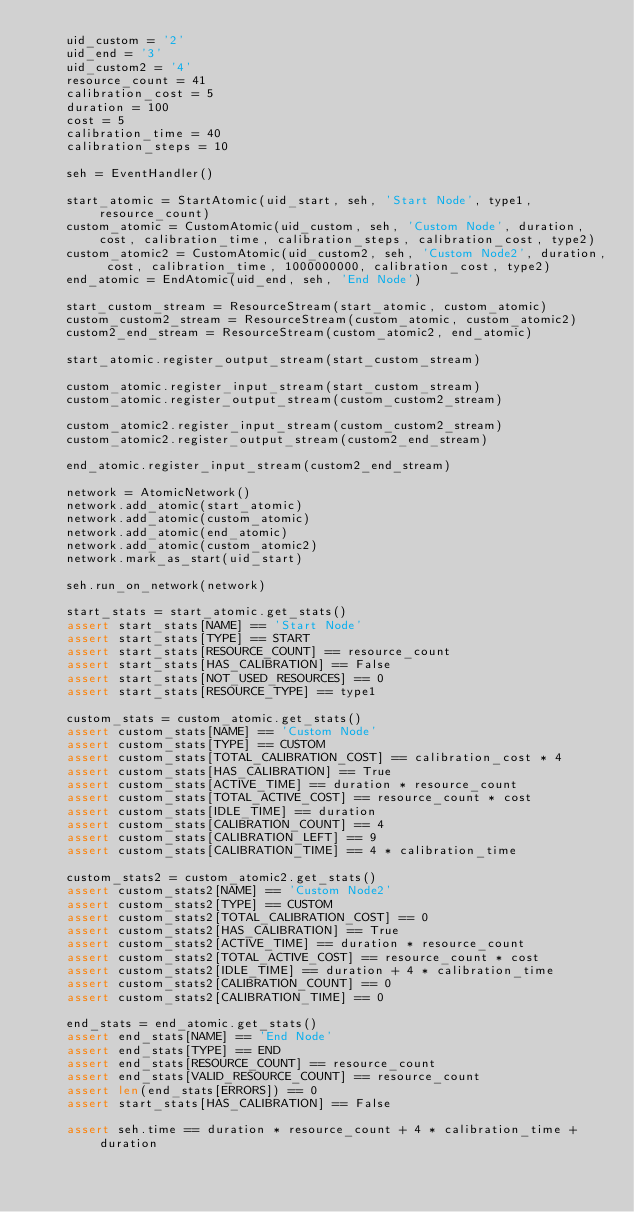<code> <loc_0><loc_0><loc_500><loc_500><_Python_>    uid_custom = '2'
    uid_end = '3'
    uid_custom2 = '4'
    resource_count = 41
    calibration_cost = 5
    duration = 100
    cost = 5
    calibration_time = 40
    calibration_steps = 10

    seh = EventHandler()

    start_atomic = StartAtomic(uid_start, seh, 'Start Node', type1, resource_count)
    custom_atomic = CustomAtomic(uid_custom, seh, 'Custom Node', duration, cost, calibration_time, calibration_steps, calibration_cost, type2)
    custom_atomic2 = CustomAtomic(uid_custom2, seh, 'Custom Node2', duration, cost, calibration_time, 1000000000, calibration_cost, type2)
    end_atomic = EndAtomic(uid_end, seh, 'End Node')

    start_custom_stream = ResourceStream(start_atomic, custom_atomic)
    custom_custom2_stream = ResourceStream(custom_atomic, custom_atomic2)
    custom2_end_stream = ResourceStream(custom_atomic2, end_atomic)

    start_atomic.register_output_stream(start_custom_stream)

    custom_atomic.register_input_stream(start_custom_stream)
    custom_atomic.register_output_stream(custom_custom2_stream)

    custom_atomic2.register_input_stream(custom_custom2_stream)
    custom_atomic2.register_output_stream(custom2_end_stream)

    end_atomic.register_input_stream(custom2_end_stream)

    network = AtomicNetwork()
    network.add_atomic(start_atomic)
    network.add_atomic(custom_atomic)
    network.add_atomic(end_atomic)
    network.add_atomic(custom_atomic2)
    network.mark_as_start(uid_start)

    seh.run_on_network(network)

    start_stats = start_atomic.get_stats()
    assert start_stats[NAME] == 'Start Node'
    assert start_stats[TYPE] == START
    assert start_stats[RESOURCE_COUNT] == resource_count
    assert start_stats[HAS_CALIBRATION] == False
    assert start_stats[NOT_USED_RESOURCES] == 0
    assert start_stats[RESOURCE_TYPE] == type1

    custom_stats = custom_atomic.get_stats()
    assert custom_stats[NAME] == 'Custom Node'
    assert custom_stats[TYPE] == CUSTOM
    assert custom_stats[TOTAL_CALIBRATION_COST] == calibration_cost * 4
    assert custom_stats[HAS_CALIBRATION] == True
    assert custom_stats[ACTIVE_TIME] == duration * resource_count
    assert custom_stats[TOTAL_ACTIVE_COST] == resource_count * cost
    assert custom_stats[IDLE_TIME] == duration
    assert custom_stats[CALIBRATION_COUNT] == 4
    assert custom_stats[CALIBRATION_LEFT] == 9
    assert custom_stats[CALIBRATION_TIME] == 4 * calibration_time

    custom_stats2 = custom_atomic2.get_stats()
    assert custom_stats2[NAME] == 'Custom Node2'
    assert custom_stats2[TYPE] == CUSTOM
    assert custom_stats2[TOTAL_CALIBRATION_COST] == 0
    assert custom_stats2[HAS_CALIBRATION] == True
    assert custom_stats2[ACTIVE_TIME] == duration * resource_count
    assert custom_stats2[TOTAL_ACTIVE_COST] == resource_count * cost
    assert custom_stats2[IDLE_TIME] == duration + 4 * calibration_time
    assert custom_stats2[CALIBRATION_COUNT] == 0
    assert custom_stats2[CALIBRATION_TIME] == 0

    end_stats = end_atomic.get_stats()
    assert end_stats[NAME] == 'End Node'
    assert end_stats[TYPE] == END
    assert end_stats[RESOURCE_COUNT] == resource_count
    assert end_stats[VALID_RESOURCE_COUNT] == resource_count
    assert len(end_stats[ERRORS]) == 0
    assert start_stats[HAS_CALIBRATION] == False

    assert seh.time == duration * resource_count + 4 * calibration_time + duration</code> 